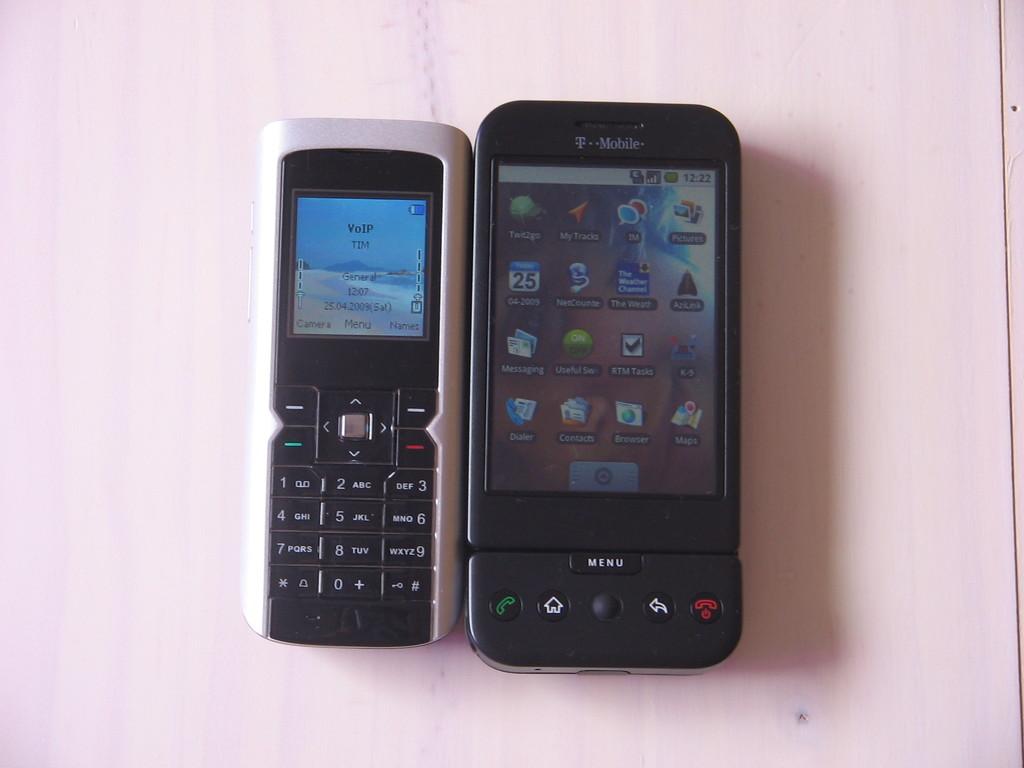What cell service is the phone on the right with?
Give a very brief answer. T-mobile. What time is it on the phone on the right?
Offer a very short reply. 12:22. 